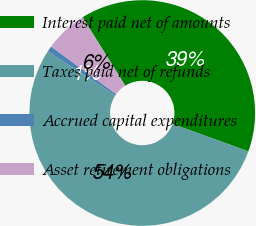<chart> <loc_0><loc_0><loc_500><loc_500><pie_chart><fcel>Interest paid net of amounts<fcel>Taxes paid net of refunds<fcel>Accrued capital expenditures<fcel>Asset retirement obligations<nl><fcel>39.4%<fcel>53.7%<fcel>0.81%<fcel>6.1%<nl></chart> 